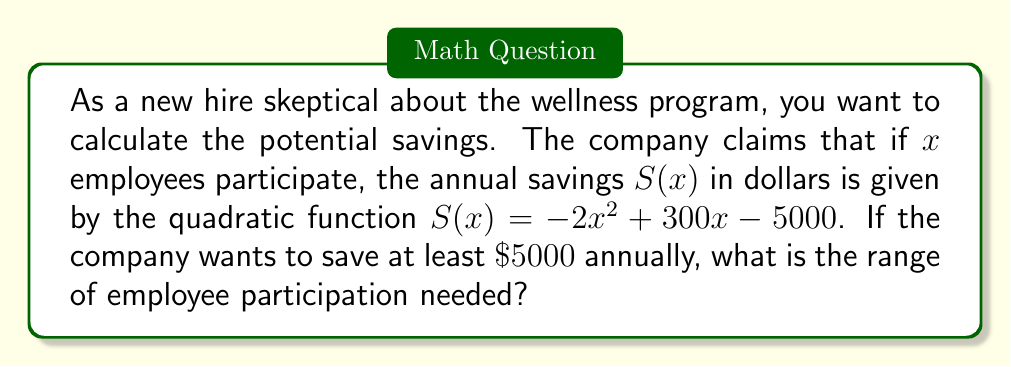Give your solution to this math problem. Let's approach this step-by-step:

1) We need to find the values of $x$ that satisfy the inequality:
   $S(x) \geq 5000$

2) Substituting the function:
   $-2x^2 + 300x - 5000 \geq 5000$

3) Simplify by moving all terms to one side:
   $-2x^2 + 300x - 10000 \geq 0$

4) This is a quadratic inequality. To solve it, we first find the roots of the corresponding quadratic equation:
   $-2x^2 + 300x - 10000 = 0$

5) We can solve this using the quadratic formula: $x = \frac{-b \pm \sqrt{b^2 - 4ac}}{2a}$
   Where $a=-2$, $b=300$, and $c=-10000$

6) Calculating:
   $x = \frac{-300 \pm \sqrt{300^2 - 4(-2)(-10000)}}{2(-2)}$
   $= \frac{-300 \pm \sqrt{90000 - 80000}}{-4}$
   $= \frac{-300 \pm \sqrt{10000}}{-4}$
   $= \frac{-300 \pm 100}{-4}$

7) This gives us two roots:
   $x_1 = \frac{-300 + 100}{-4} = 50$
   $x_2 = \frac{-300 - 100}{-4} = 100$

8) The parabola opens downward because $a$ is negative. Therefore, the inequality is satisfied between these two roots.

9) Thus, the range of employee participation needed is $50 \leq x \leq 100$.
Answer: $50 \leq x \leq 100$ 